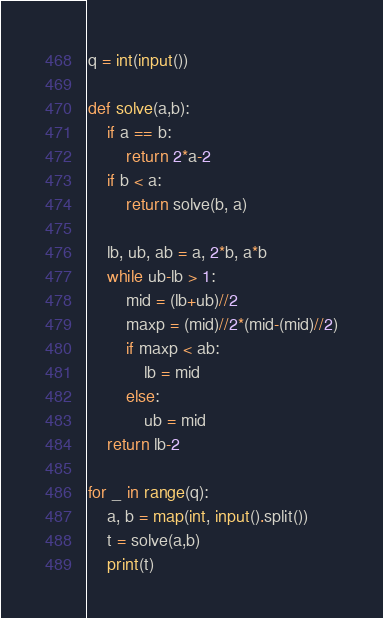Convert code to text. <code><loc_0><loc_0><loc_500><loc_500><_Python_>q = int(input())

def solve(a,b):
    if a == b:
        return 2*a-2
    if b < a:
        return solve(b, a)

    lb, ub, ab = a, 2*b, a*b
    while ub-lb > 1:
        mid = (lb+ub)//2
        maxp = (mid)//2*(mid-(mid)//2)
        if maxp < ab:
            lb = mid
        else:
            ub = mid
    return lb-2

for _ in range(q):
    a, b = map(int, input().split())
    t = solve(a,b)
    print(t)
</code> 